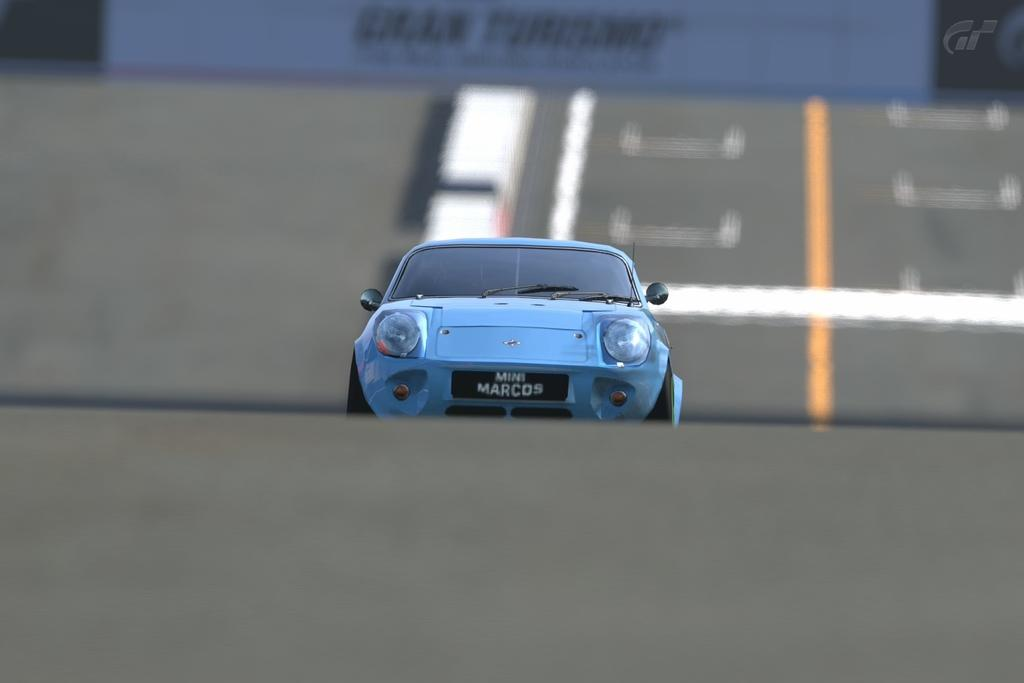What color is the car in the image? The car in the image is blue. Where is the car located in the image? The car is on the road in the image. What is at the top of the image? There is a banner at the top of the image. What can be seen on the right side of the road in the image? There are white and yellow lines on the right side of the road in the image. What type of creature is hiding under the car in the image? There is no creature present under the car in the image. 